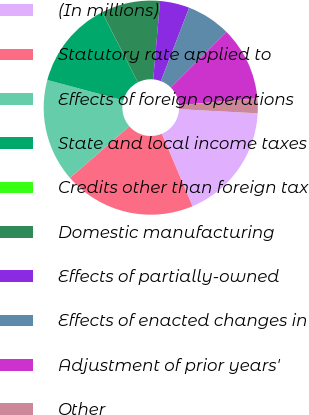Convert chart. <chart><loc_0><loc_0><loc_500><loc_500><pie_chart><fcel>(In millions)<fcel>Statutory rate applied to<fcel>Effects of foreign operations<fcel>State and local income taxes<fcel>Credits other than foreign tax<fcel>Domestic manufacturing<fcel>Effects of partially-owned<fcel>Effects of enacted changes in<fcel>Adjustment of prior years'<fcel>Other<nl><fcel>17.77%<fcel>19.99%<fcel>15.55%<fcel>13.33%<fcel>0.01%<fcel>8.89%<fcel>4.45%<fcel>6.67%<fcel>11.11%<fcel>2.23%<nl></chart> 